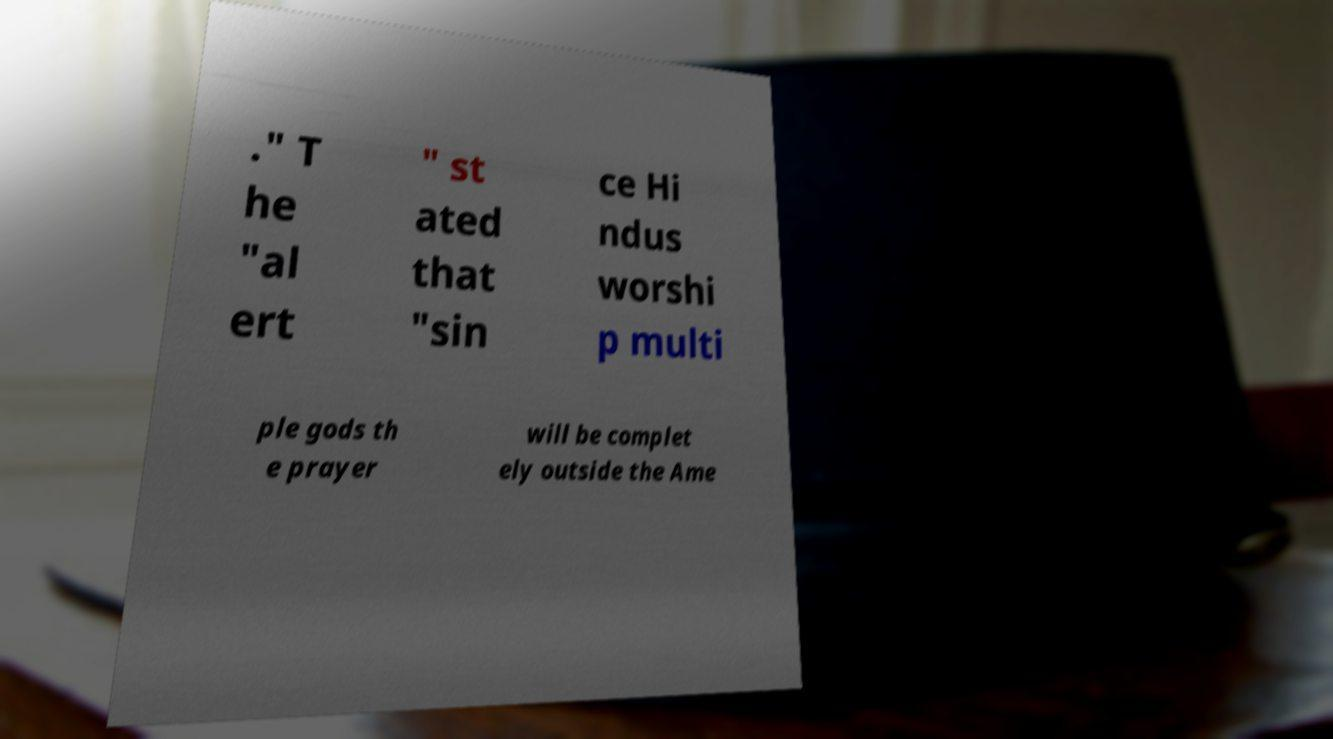Could you assist in decoding the text presented in this image and type it out clearly? ." T he "al ert " st ated that "sin ce Hi ndus worshi p multi ple gods th e prayer will be complet ely outside the Ame 